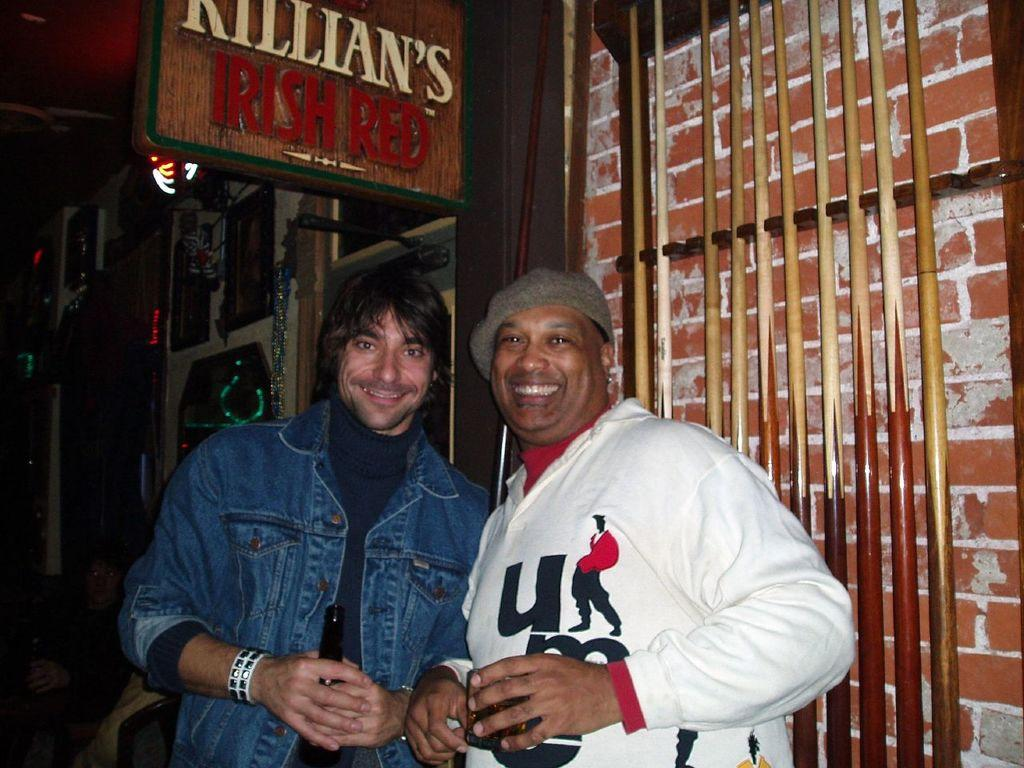<image>
Share a concise interpretation of the image provided. Two friends pose beneath a Killian's Irish Red sign. 